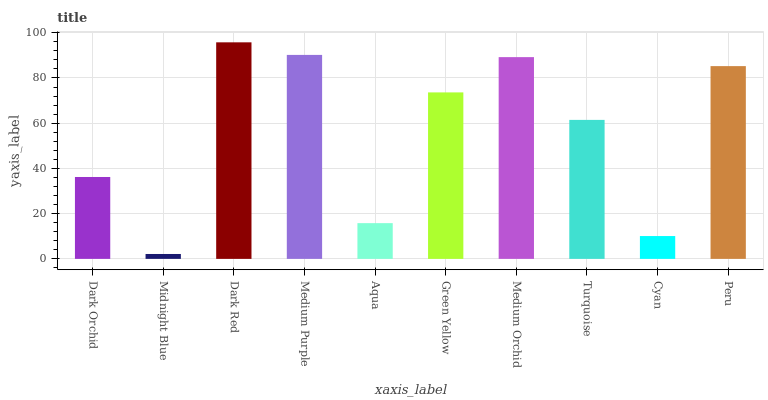Is Midnight Blue the minimum?
Answer yes or no. Yes. Is Dark Red the maximum?
Answer yes or no. Yes. Is Dark Red the minimum?
Answer yes or no. No. Is Midnight Blue the maximum?
Answer yes or no. No. Is Dark Red greater than Midnight Blue?
Answer yes or no. Yes. Is Midnight Blue less than Dark Red?
Answer yes or no. Yes. Is Midnight Blue greater than Dark Red?
Answer yes or no. No. Is Dark Red less than Midnight Blue?
Answer yes or no. No. Is Green Yellow the high median?
Answer yes or no. Yes. Is Turquoise the low median?
Answer yes or no. Yes. Is Medium Orchid the high median?
Answer yes or no. No. Is Dark Orchid the low median?
Answer yes or no. No. 